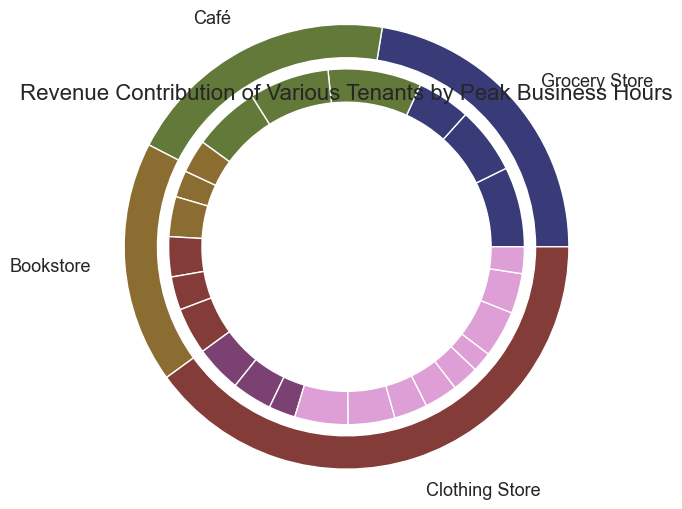What is the total revenue contributed by the Grocery Store? The Grocery Store's revenue contributions include the weekday and weekend revenues: (4000 + 6000 + 5000) for weekdays and (5000 + 7000 + 6000) for weekends. Summing these values together: 4000 + 6000 + 5000 + 5000 + 7000 + 6000 = 33000.
Answer: 33000 Which tenant has the highest total revenue contribution? By looking at the outer pie chart, the segment representing the Grocery Store appears to be the largest, indicating it has the highest total revenue contribution compared to the other tenants.
Answer: Grocery Store How much more revenue does the Café generate on weekends compared to weekdays? To find the revenue difference: (3500 + 3000 + 2500) for weekends minus (3000 + 2500 + 2000) for weekdays. So, (3500 + 3000 + 2500) - (3000 + 2500 + 2000) = 9000 - 7500 = 1500.
Answer: 1500 What percentage of the total revenue is contributed by the Bookstore in the afternoon on weekends? First, find the Bookstore's weekend afternoon revenue: 4000. Then, calculate the total revenue contribution by summing up all tenant revenues, which is (33000+ 13500 + 18500 + 14500 = 79500). So, (4000 / 79500) * 100 ≈ 5.03%.
Answer: 5.03% Which tenant has a larger morning revenue on weekends, the Clothing Store or the Bookstore? Compare the morning revenues on weekends: Clothing Store's (2000) and Bookstore's (2500). The Bookstore's morning weekend revenue is higher.
Answer: Bookstore What is the total revenue contribution of all tenants during weekday afternoons? Weekday afternoon revenues are: Grocery Store (6000), Café (2500), Bookstore (3500), and Clothing Store (2500). Summing these: 6000 + 2500 + 3500 + 2500 = 14500.
Answer: 14500 Does the Bookstore generate more revenue in the afternoon or evening on weekends? Compare the weekend afternoon revenue (4000) with the evening revenue (3500) for the Bookstore. The afternoon revenue is higher.
Answer: Afternoon Which time period generates the least revenue for the Café on weekdays? By comparing the weekday morning (3000), afternoon (2500), and evening (2000) revenues for the Café, the evening period has the least revenue.
Answer: Evening How many tenants generate more revenue on weekdays during the afternoon compared to the evening? Compare the weekday afternoon and evening revenues for each tenant: Grocery Store (6000 vs 5000), Café (2500 vs 2000), Bookstore (3500 vs 3000), Clothing Store (2500 vs 2000). All tenants generate more revenue in the afternoon.
Answer: 4 